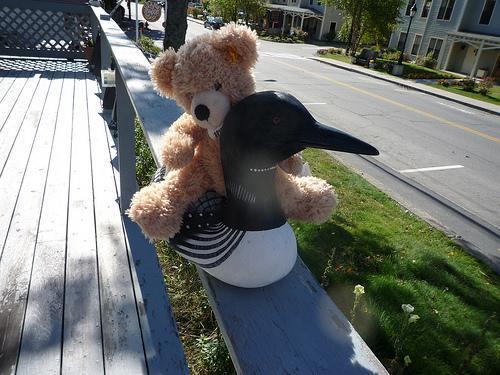How many bears are there?
Give a very brief answer. 1. How many characters are in the photo?
Give a very brief answer. 2. 